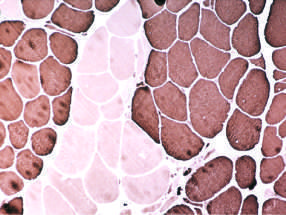do large clusters of fibers appear that all share the same fiber type (fiber type grouping)?
Answer the question using a single word or phrase. Yes 